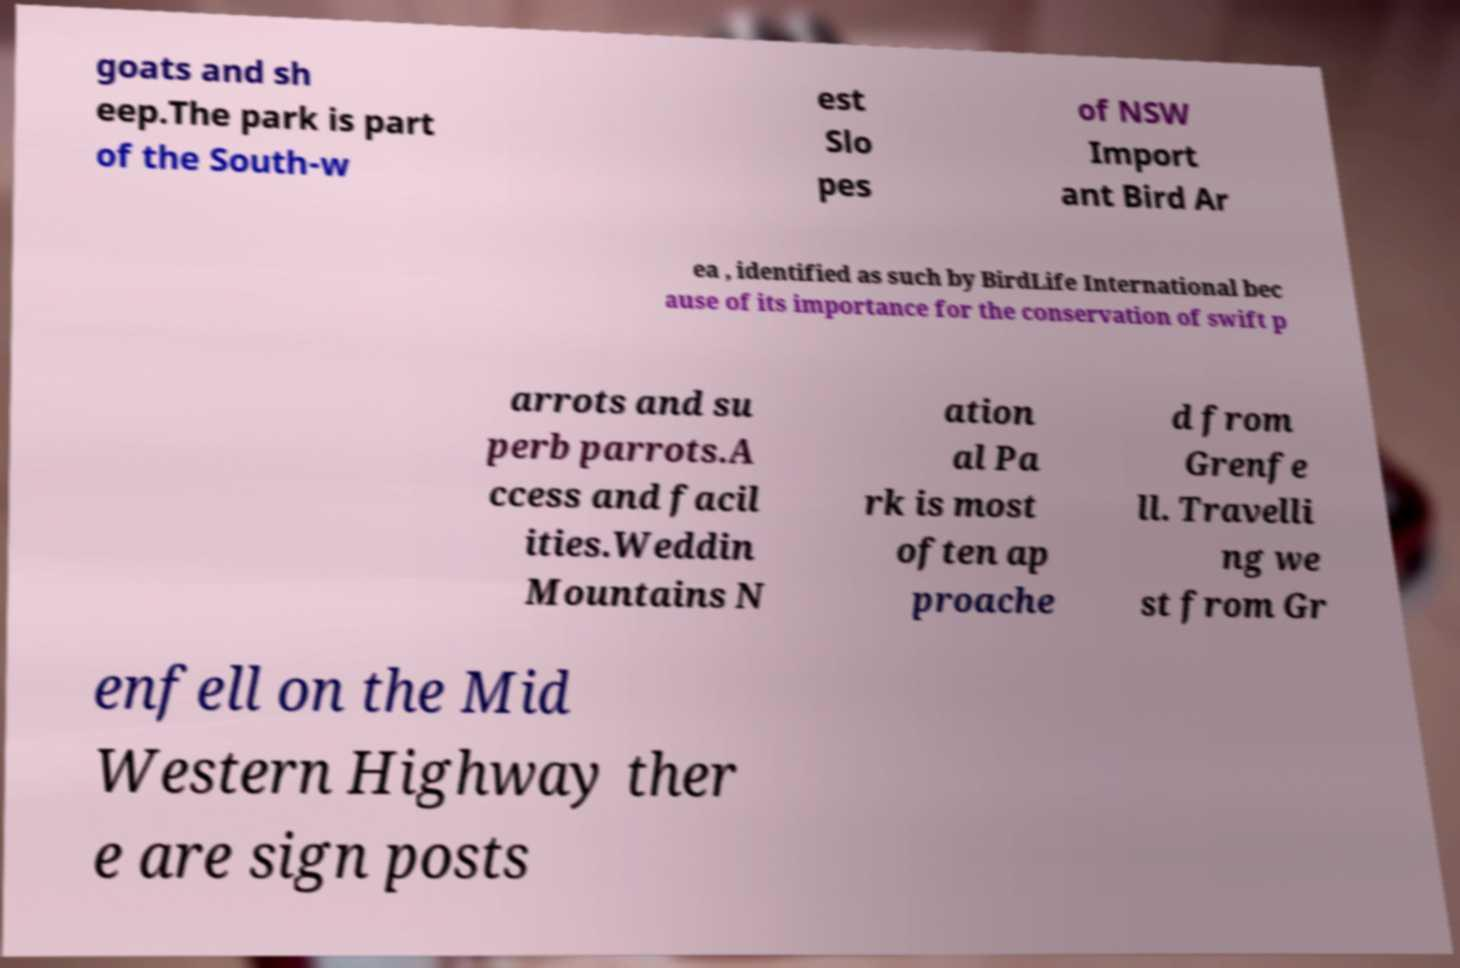For documentation purposes, I need the text within this image transcribed. Could you provide that? goats and sh eep.The park is part of the South-w est Slo pes of NSW Import ant Bird Ar ea , identified as such by BirdLife International bec ause of its importance for the conservation of swift p arrots and su perb parrots.A ccess and facil ities.Weddin Mountains N ation al Pa rk is most often ap proache d from Grenfe ll. Travelli ng we st from Gr enfell on the Mid Western Highway ther e are sign posts 